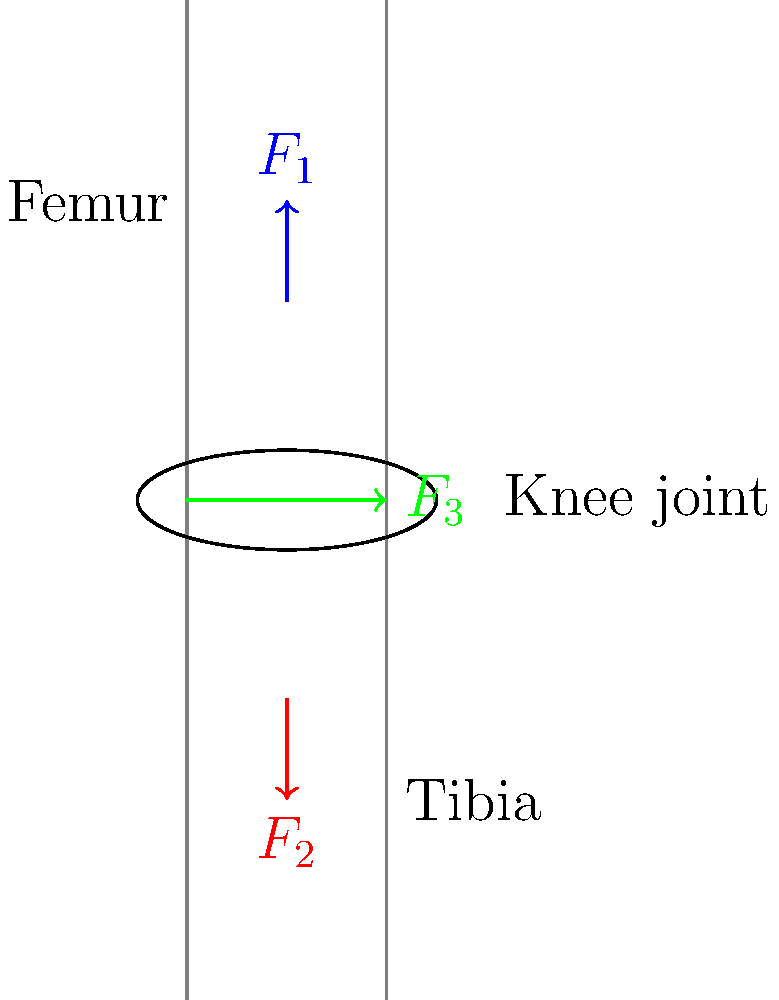In the diagram of a human knee joint during walking, three main forces are represented: $F_1$ (blue, pointing downward), $F_2$ (red, pointing upward), and $F_3$ (green, pointing laterally). Assuming the knee is in equilibrium during the stance phase of walking, which of these forces is likely to represent the joint reaction force, and what is its relationship to the other two forces? To answer this question, we need to consider the principles of biomechanics and force equilibrium:

1. In a joint at equilibrium, the sum of all forces must equal zero.

2. The forces acting on the knee during walking include:
   - Muscle forces (primarily from the quadriceps)
   - Weight-bearing forces
   - Joint reaction forces

3. Analyzing the diagram:
   - $F_1$ (blue, downward) likely represents the weight-bearing force or a component of it.
   - $F_2$ (red, upward) likely represents the muscle force from the quadriceps.
   - $F_3$ (green, lateral) is the only force that doesn't align with the long axis of the leg, suggesting it's the joint reaction force.

4. For equilibrium in the vertical direction:
   $F_1 = F_2$

5. The joint reaction force ($F_3$) must balance the resultant of $F_1$ and $F_2$.

6. Using vector addition, we can deduce that $F_3$ must be equal in magnitude and opposite in direction to the vector sum of $F_1$ and $F_2$.

Therefore, $F_3$ represents the joint reaction force, and its magnitude and direction are determined by the vector sum of $F_1$ and $F_2$.
Answer: $F_3$ is the joint reaction force, equal and opposite to the vector sum of $F_1$ and $F_2$. 